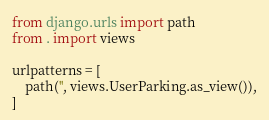<code> <loc_0><loc_0><loc_500><loc_500><_Python_>from django.urls import path
from . import views

urlpatterns = [
    path('', views.UserParking.as_view()),
]</code> 